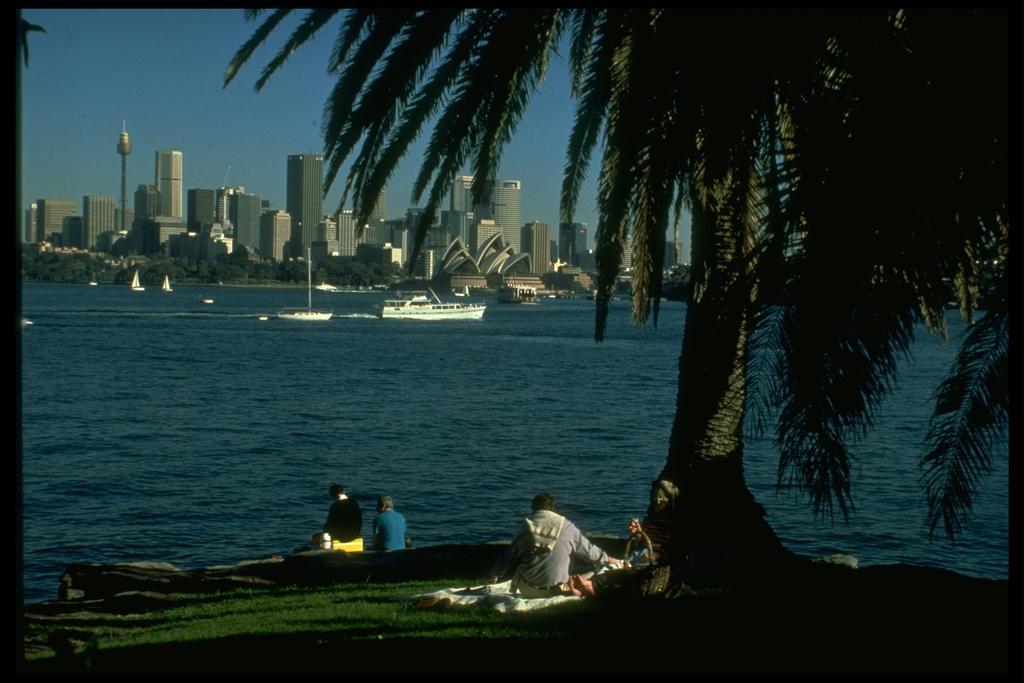How would you summarize this image in a sentence or two? In this image I can see an open ground in the front and on it I can see few people are sitting. I can also see a tree, a basket, a white colour cloth and few other things on the ground. In the background I can see water, number of buildings, number of trees, the sky and number of boats on the water. 